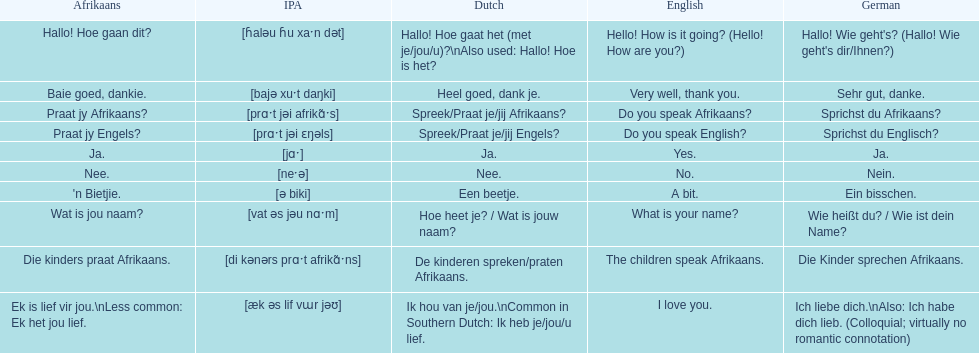Can you provide the english translation for 'n bietjie? A bit. 